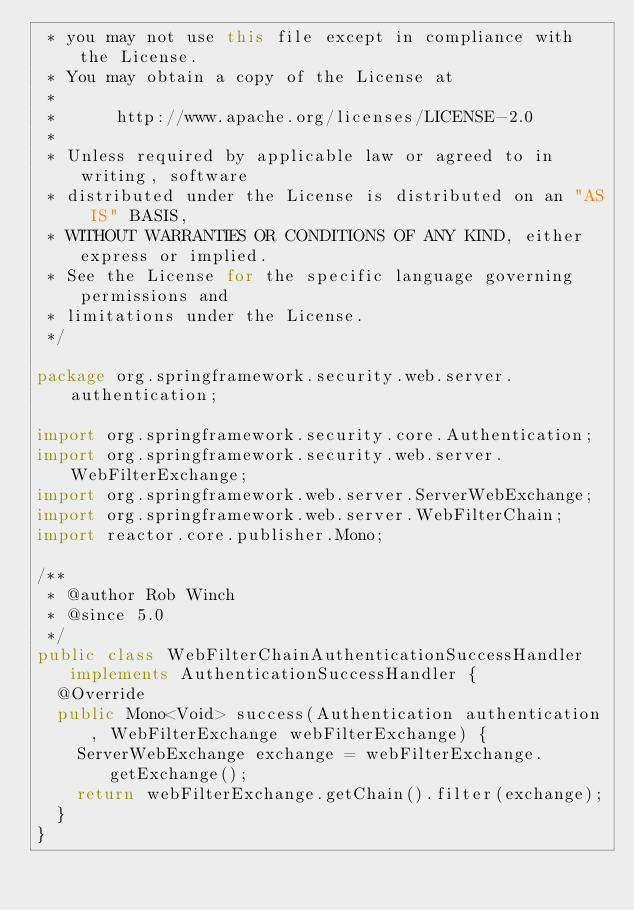Convert code to text. <code><loc_0><loc_0><loc_500><loc_500><_Java_> * you may not use this file except in compliance with the License.
 * You may obtain a copy of the License at
 *
 *      http://www.apache.org/licenses/LICENSE-2.0
 *
 * Unless required by applicable law or agreed to in writing, software
 * distributed under the License is distributed on an "AS IS" BASIS,
 * WITHOUT WARRANTIES OR CONDITIONS OF ANY KIND, either express or implied.
 * See the License for the specific language governing permissions and
 * limitations under the License.
 */

package org.springframework.security.web.server.authentication;

import org.springframework.security.core.Authentication;
import org.springframework.security.web.server.WebFilterExchange;
import org.springframework.web.server.ServerWebExchange;
import org.springframework.web.server.WebFilterChain;
import reactor.core.publisher.Mono;

/**
 * @author Rob Winch
 * @since 5.0
 */
public class WebFilterChainAuthenticationSuccessHandler implements AuthenticationSuccessHandler {
	@Override
	public Mono<Void> success(Authentication authentication, WebFilterExchange webFilterExchange) {
		ServerWebExchange exchange = webFilterExchange.getExchange();
		return webFilterExchange.getChain().filter(exchange);
	}
}
</code> 